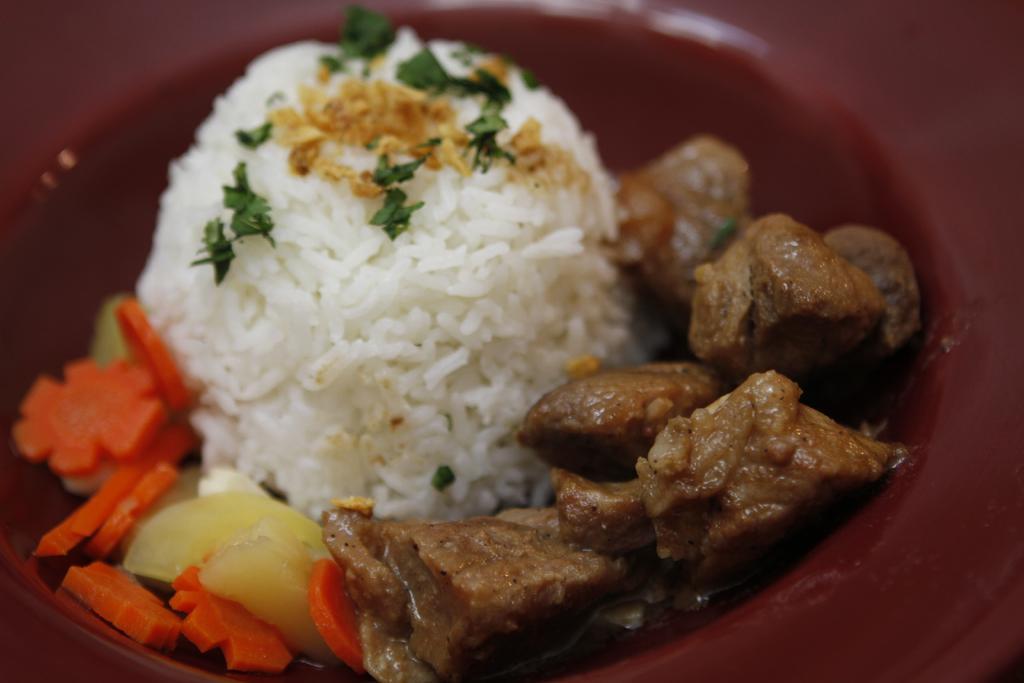Can you describe this image briefly? This image consists of a bowl in which we can see the rice along with meat and carrot slices. 